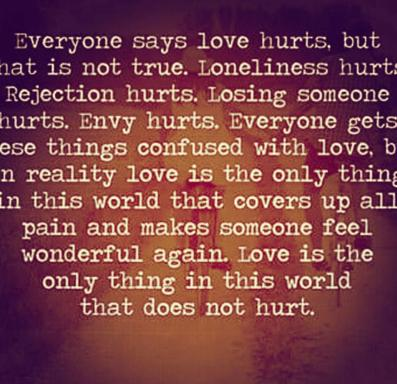Why might the text suggest that common perceptions of love are incorrect? The text challenges common perceptions by stating that whereas many believe love is painful, based on experiences of loneliness, rejection, and loss, true love in its purest form actually heals rather than harms. This stands to correct the misguided equating of negative emotional states with love, promoting a healthier understanding. 